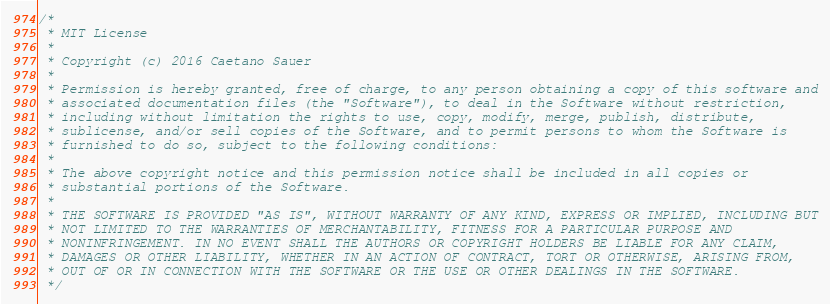<code> <loc_0><loc_0><loc_500><loc_500><_C_>/*
 * MIT License
 *
 * Copyright (c) 2016 Caetano Sauer
 *
 * Permission is hereby granted, free of charge, to any person obtaining a copy of this software and
 * associated documentation files (the "Software"), to deal in the Software without restriction,
 * including without limitation the rights to use, copy, modify, merge, publish, distribute,
 * sublicense, and/or sell copies of the Software, and to permit persons to whom the Software is
 * furnished to do so, subject to the following conditions:
 *
 * The above copyright notice and this permission notice shall be included in all copies or
 * substantial portions of the Software.
 *
 * THE SOFTWARE IS PROVIDED "AS IS", WITHOUT WARRANTY OF ANY KIND, EXPRESS OR IMPLIED, INCLUDING BUT
 * NOT LIMITED TO THE WARRANTIES OF MERCHANTABILITY, FITNESS FOR A PARTICULAR PURPOSE AND
 * NONINFRINGEMENT. IN NO EVENT SHALL THE AUTHORS OR COPYRIGHT HOLDERS BE LIABLE FOR ANY CLAIM,
 * DAMAGES OR OTHER LIABILITY, WHETHER IN AN ACTION OF CONTRACT, TORT OR OTHERWISE, ARISING FROM,
 * OUT OF OR IN CONNECTION WITH THE SOFTWARE OR THE USE OR OTHER DEALINGS IN THE SOFTWARE.
 */
</code> 